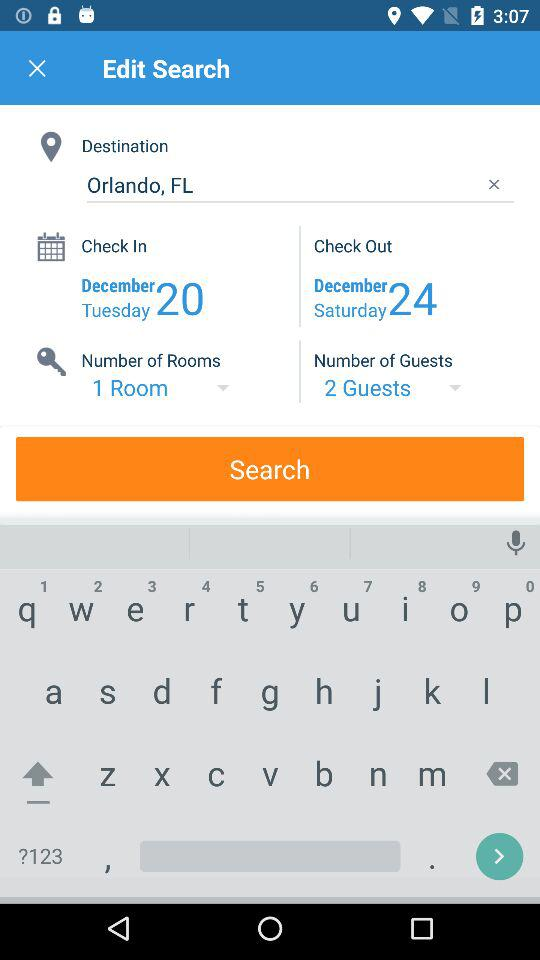What is the check-out date? The check-out date is Saturday, 24th December. 